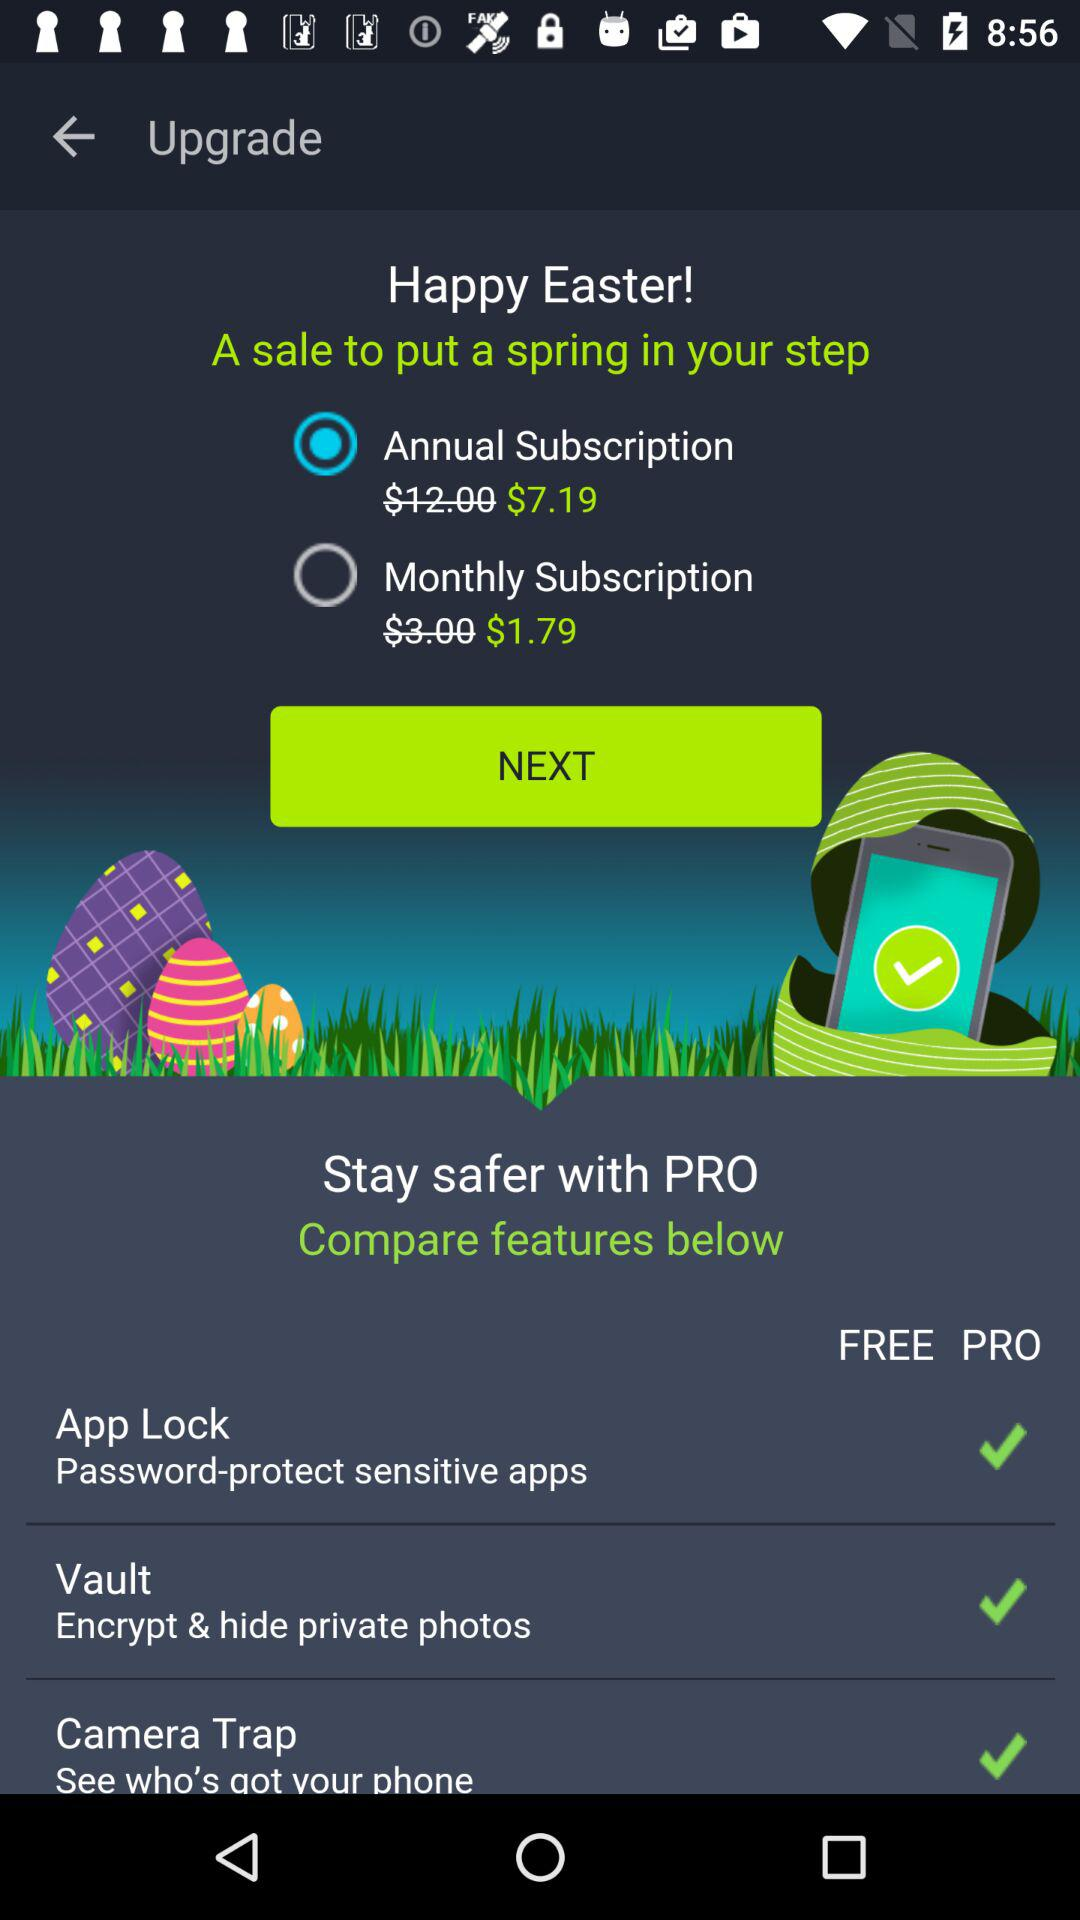Which feature is not available in the free version?
Answer the question using a single word or phrase. Camera Trap 